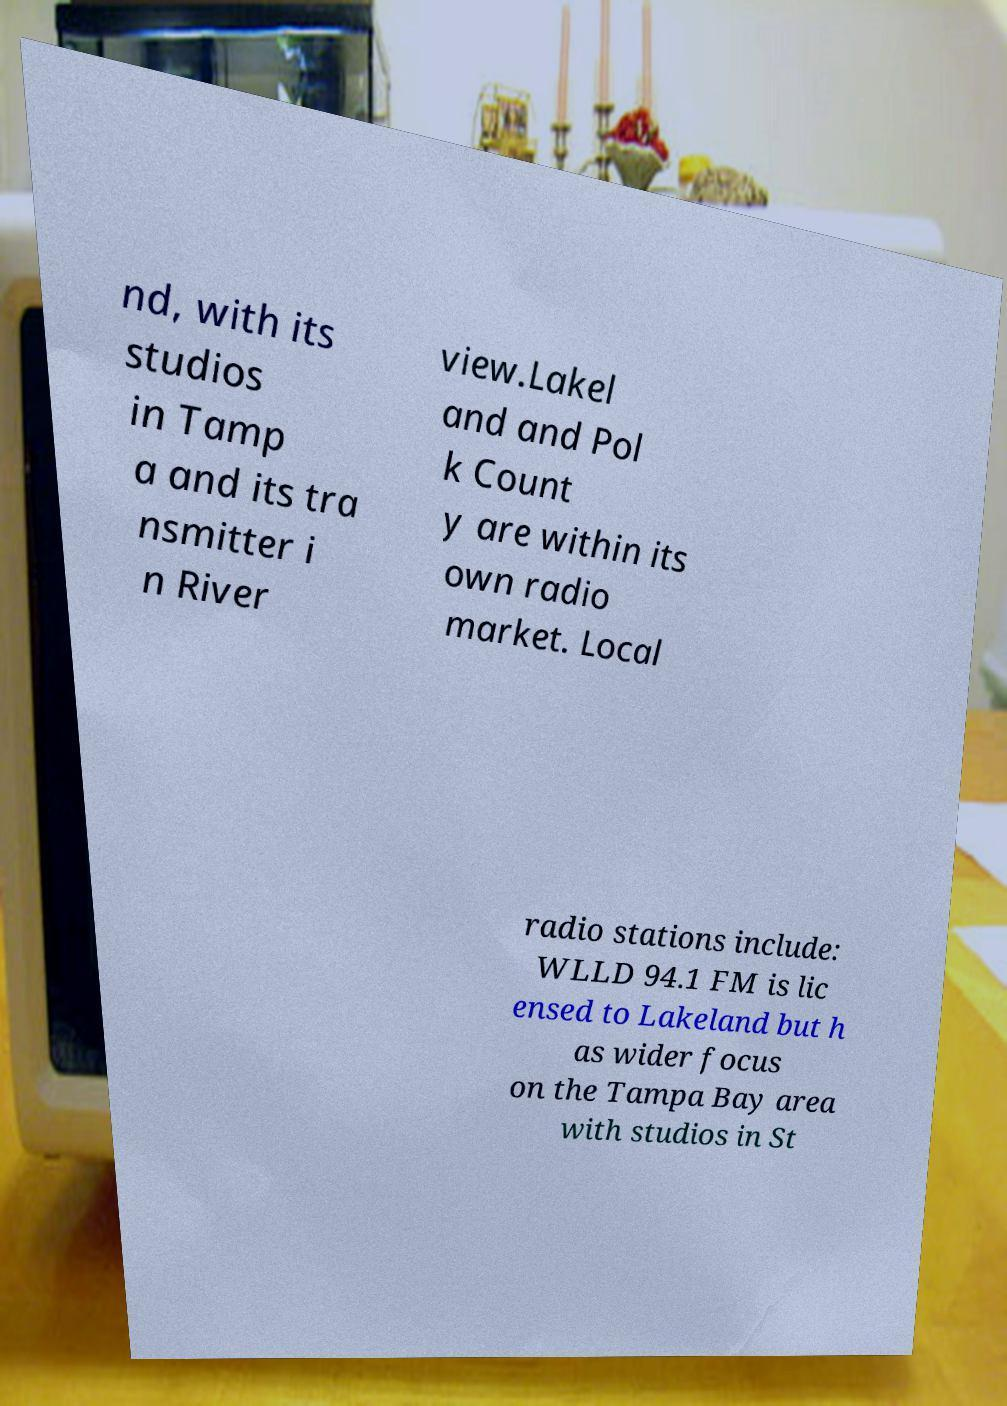Can you read and provide the text displayed in the image?This photo seems to have some interesting text. Can you extract and type it out for me? nd, with its studios in Tamp a and its tra nsmitter i n River view.Lakel and and Pol k Count y are within its own radio market. Local radio stations include: WLLD 94.1 FM is lic ensed to Lakeland but h as wider focus on the Tampa Bay area with studios in St 